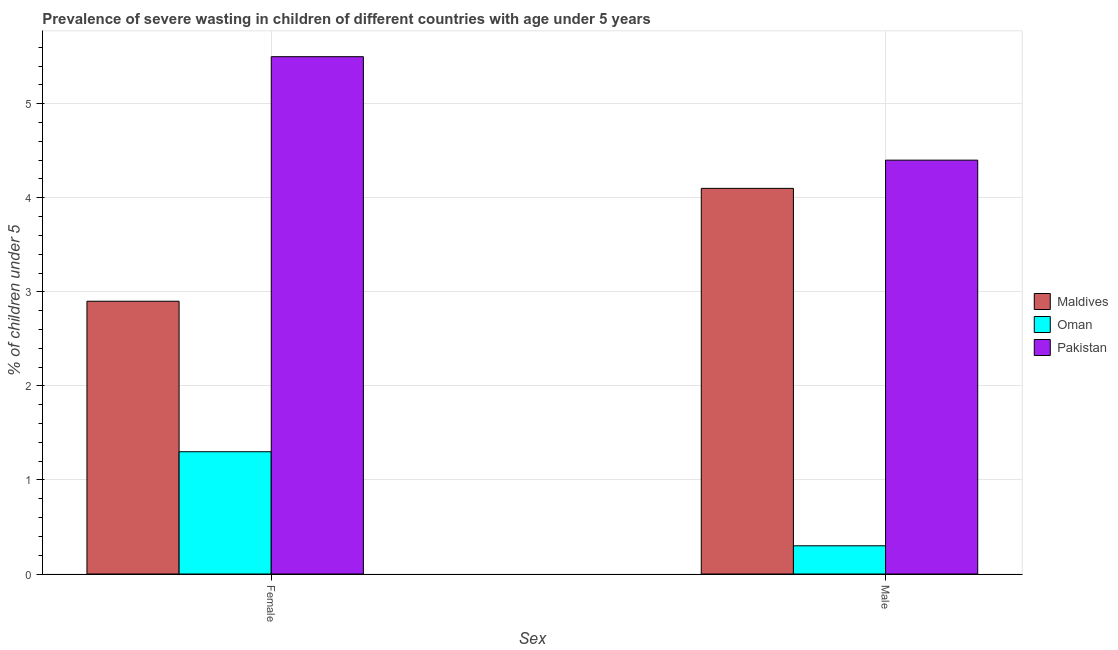How many groups of bars are there?
Provide a short and direct response. 2. Are the number of bars per tick equal to the number of legend labels?
Your answer should be compact. Yes. What is the percentage of undernourished female children in Maldives?
Offer a terse response. 2.9. Across all countries, what is the minimum percentage of undernourished male children?
Give a very brief answer. 0.3. In which country was the percentage of undernourished male children minimum?
Make the answer very short. Oman. What is the total percentage of undernourished male children in the graph?
Offer a very short reply. 8.8. What is the difference between the percentage of undernourished male children in Oman and that in Maldives?
Keep it short and to the point. -3.8. What is the difference between the percentage of undernourished female children in Oman and the percentage of undernourished male children in Pakistan?
Your response must be concise. -3.1. What is the average percentage of undernourished female children per country?
Your answer should be compact. 3.23. What is the difference between the percentage of undernourished female children and percentage of undernourished male children in Pakistan?
Your answer should be very brief. 1.1. What is the ratio of the percentage of undernourished male children in Pakistan to that in Oman?
Make the answer very short. 14.67. In how many countries, is the percentage of undernourished female children greater than the average percentage of undernourished female children taken over all countries?
Provide a succinct answer. 1. What does the 2nd bar from the left in Female represents?
Make the answer very short. Oman. What does the 2nd bar from the right in Female represents?
Make the answer very short. Oman. How many bars are there?
Your answer should be very brief. 6. What is the difference between two consecutive major ticks on the Y-axis?
Offer a terse response. 1. Are the values on the major ticks of Y-axis written in scientific E-notation?
Ensure brevity in your answer.  No. Does the graph contain any zero values?
Offer a terse response. No. Does the graph contain grids?
Offer a terse response. Yes. What is the title of the graph?
Ensure brevity in your answer.  Prevalence of severe wasting in children of different countries with age under 5 years. What is the label or title of the X-axis?
Your answer should be compact. Sex. What is the label or title of the Y-axis?
Offer a very short reply.  % of children under 5. What is the  % of children under 5 in Maldives in Female?
Your response must be concise. 2.9. What is the  % of children under 5 in Oman in Female?
Ensure brevity in your answer.  1.3. What is the  % of children under 5 of Maldives in Male?
Your response must be concise. 4.1. What is the  % of children under 5 in Oman in Male?
Offer a terse response. 0.3. What is the  % of children under 5 of Pakistan in Male?
Offer a very short reply. 4.4. Across all Sex, what is the maximum  % of children under 5 of Maldives?
Offer a terse response. 4.1. Across all Sex, what is the maximum  % of children under 5 of Oman?
Make the answer very short. 1.3. Across all Sex, what is the maximum  % of children under 5 in Pakistan?
Offer a very short reply. 5.5. Across all Sex, what is the minimum  % of children under 5 in Maldives?
Make the answer very short. 2.9. Across all Sex, what is the minimum  % of children under 5 in Oman?
Your answer should be compact. 0.3. Across all Sex, what is the minimum  % of children under 5 of Pakistan?
Give a very brief answer. 4.4. What is the total  % of children under 5 in Maldives in the graph?
Your answer should be very brief. 7. What is the total  % of children under 5 in Pakistan in the graph?
Provide a short and direct response. 9.9. What is the difference between the  % of children under 5 in Pakistan in Female and that in Male?
Provide a succinct answer. 1.1. What is the difference between the  % of children under 5 of Maldives in Female and the  % of children under 5 of Oman in Male?
Your answer should be very brief. 2.6. What is the difference between the  % of children under 5 of Maldives in Female and the  % of children under 5 of Pakistan in Male?
Your response must be concise. -1.5. What is the difference between the  % of children under 5 in Oman in Female and the  % of children under 5 in Pakistan in Male?
Your answer should be compact. -3.1. What is the average  % of children under 5 of Pakistan per Sex?
Provide a short and direct response. 4.95. What is the difference between the  % of children under 5 in Maldives and  % of children under 5 in Oman in Female?
Give a very brief answer. 1.6. What is the difference between the  % of children under 5 of Maldives and  % of children under 5 of Pakistan in Female?
Your answer should be compact. -2.6. What is the difference between the  % of children under 5 of Maldives and  % of children under 5 of Pakistan in Male?
Provide a short and direct response. -0.3. What is the difference between the  % of children under 5 of Oman and  % of children under 5 of Pakistan in Male?
Keep it short and to the point. -4.1. What is the ratio of the  % of children under 5 of Maldives in Female to that in Male?
Offer a very short reply. 0.71. What is the ratio of the  % of children under 5 of Oman in Female to that in Male?
Your answer should be very brief. 4.33. What is the difference between the highest and the second highest  % of children under 5 of Oman?
Offer a terse response. 1. What is the difference between the highest and the second highest  % of children under 5 in Pakistan?
Give a very brief answer. 1.1. 